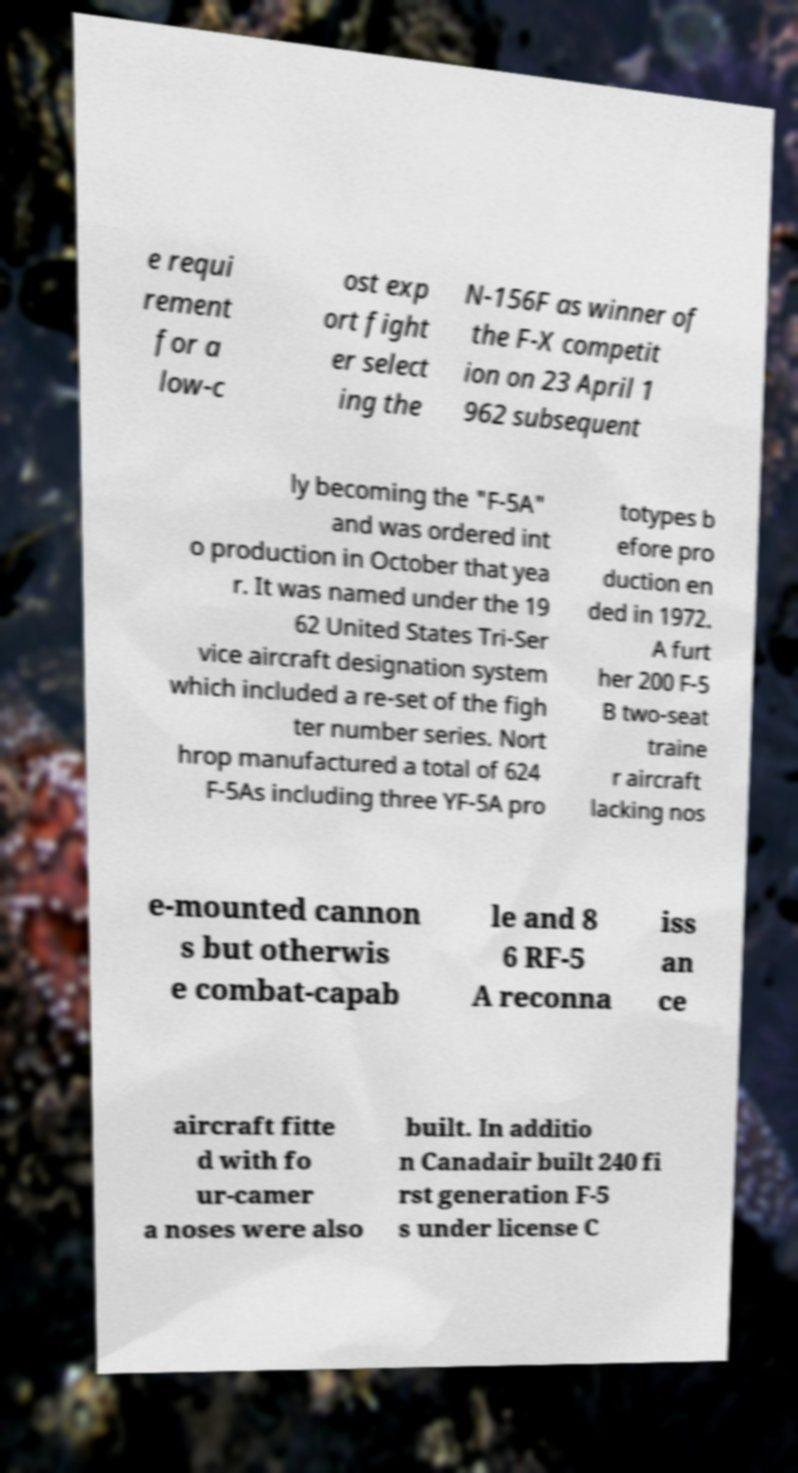What messages or text are displayed in this image? I need them in a readable, typed format. e requi rement for a low-c ost exp ort fight er select ing the N-156F as winner of the F-X competit ion on 23 April 1 962 subsequent ly becoming the "F-5A" and was ordered int o production in October that yea r. It was named under the 19 62 United States Tri-Ser vice aircraft designation system which included a re-set of the figh ter number series. Nort hrop manufactured a total of 624 F-5As including three YF-5A pro totypes b efore pro duction en ded in 1972. A furt her 200 F-5 B two-seat traine r aircraft lacking nos e-mounted cannon s but otherwis e combat-capab le and 8 6 RF-5 A reconna iss an ce aircraft fitte d with fo ur-camer a noses were also built. In additio n Canadair built 240 fi rst generation F-5 s under license C 